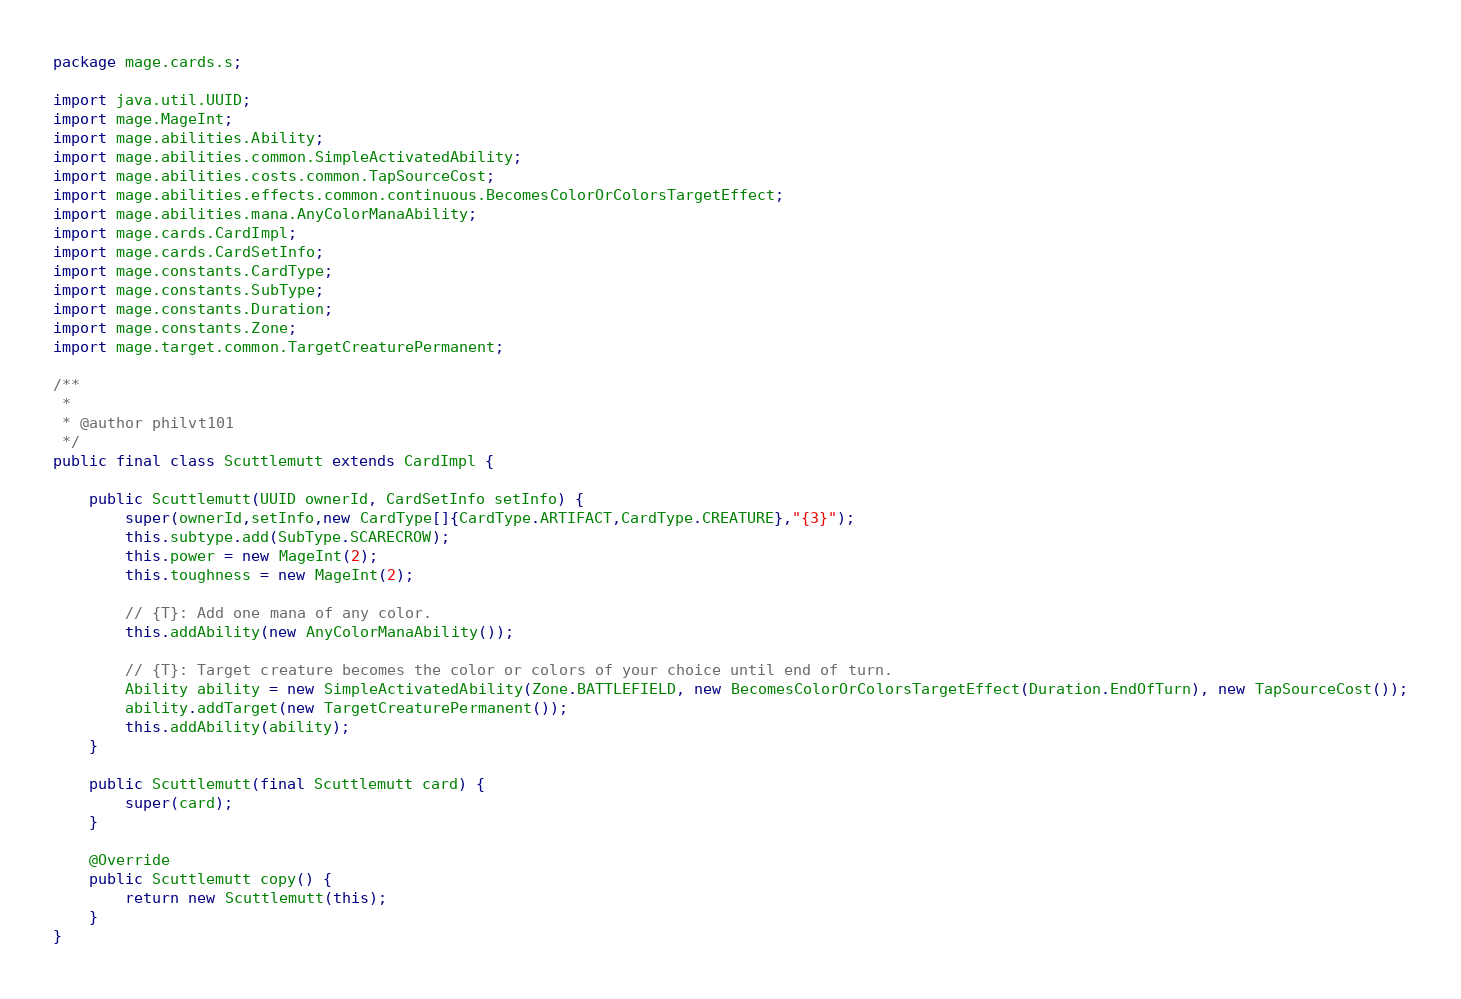Convert code to text. <code><loc_0><loc_0><loc_500><loc_500><_Java_>
package mage.cards.s;

import java.util.UUID;
import mage.MageInt;
import mage.abilities.Ability;
import mage.abilities.common.SimpleActivatedAbility;
import mage.abilities.costs.common.TapSourceCost;
import mage.abilities.effects.common.continuous.BecomesColorOrColorsTargetEffect;
import mage.abilities.mana.AnyColorManaAbility;
import mage.cards.CardImpl;
import mage.cards.CardSetInfo;
import mage.constants.CardType;
import mage.constants.SubType;
import mage.constants.Duration;
import mage.constants.Zone;
import mage.target.common.TargetCreaturePermanent;

/**
 *
 * @author philvt101
 */
public final class Scuttlemutt extends CardImpl {

    public Scuttlemutt(UUID ownerId, CardSetInfo setInfo) {
        super(ownerId,setInfo,new CardType[]{CardType.ARTIFACT,CardType.CREATURE},"{3}");
        this.subtype.add(SubType.SCARECROW);
        this.power = new MageInt(2);
        this.toughness = new MageInt(2);

        // {T}: Add one mana of any color.
        this.addAbility(new AnyColorManaAbility());

        // {T}: Target creature becomes the color or colors of your choice until end of turn.
        Ability ability = new SimpleActivatedAbility(Zone.BATTLEFIELD, new BecomesColorOrColorsTargetEffect(Duration.EndOfTurn), new TapSourceCost());
        ability.addTarget(new TargetCreaturePermanent());
        this.addAbility(ability);
    }

    public Scuttlemutt(final Scuttlemutt card) {
        super(card);
    }

    @Override
    public Scuttlemutt copy() {
        return new Scuttlemutt(this);
    }
}
</code> 